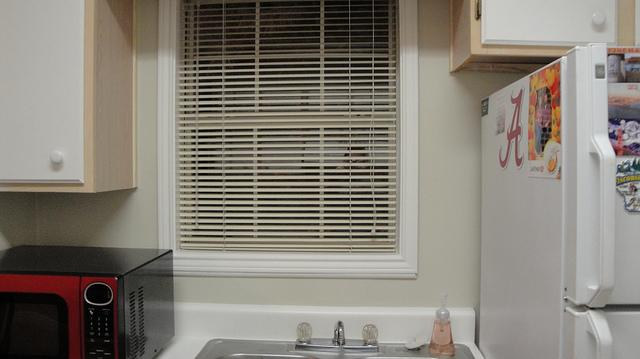Is there a curtain on the window?
Short answer required. No. What is in the room?
Keep it brief. Kitchen. Is the cabinet door closed?
Be succinct. Yes. What color is the microwave?
Answer briefly. Black. Is it daytime?
Write a very short answer. No. Is there a triangle decoration?
Concise answer only. No. Which company makes this refrigerator?
Keep it brief. Frigidaire. What's covering the refrigerator?
Quick response, please. Pictures. What is on the right of the kitchen?
Concise answer only. Refrigerator. What is in the window?
Keep it brief. Blinds. Was this photo taken in the daytime?
Write a very short answer. No. 